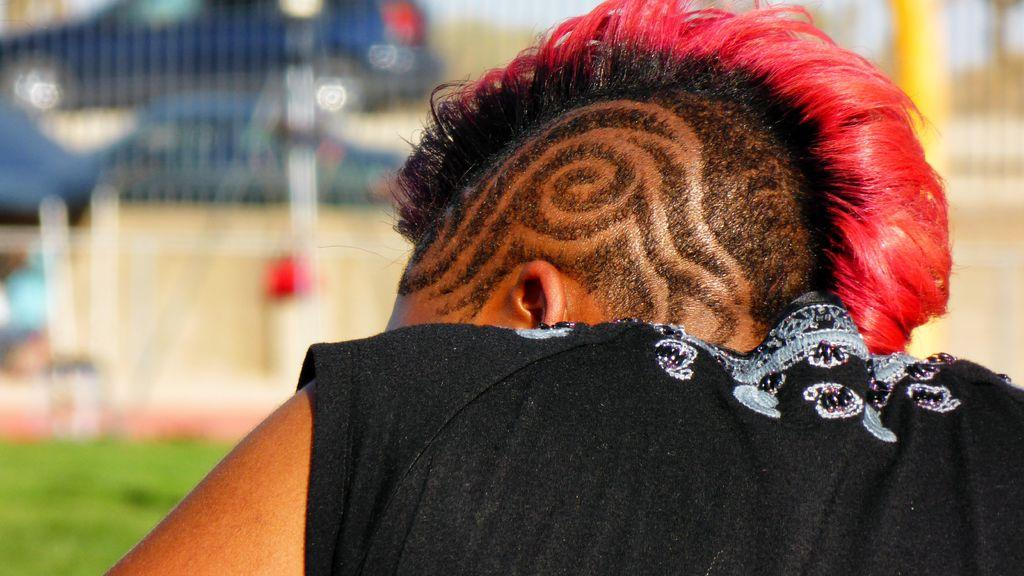Who or what is the main subject in the image? There is a person in the image. Can you describe the background of the image? The background of the image is blurry. What type of ball is the person holding in the image? There is no ball present in the image; the main subject is a person, and the background is blurry. 